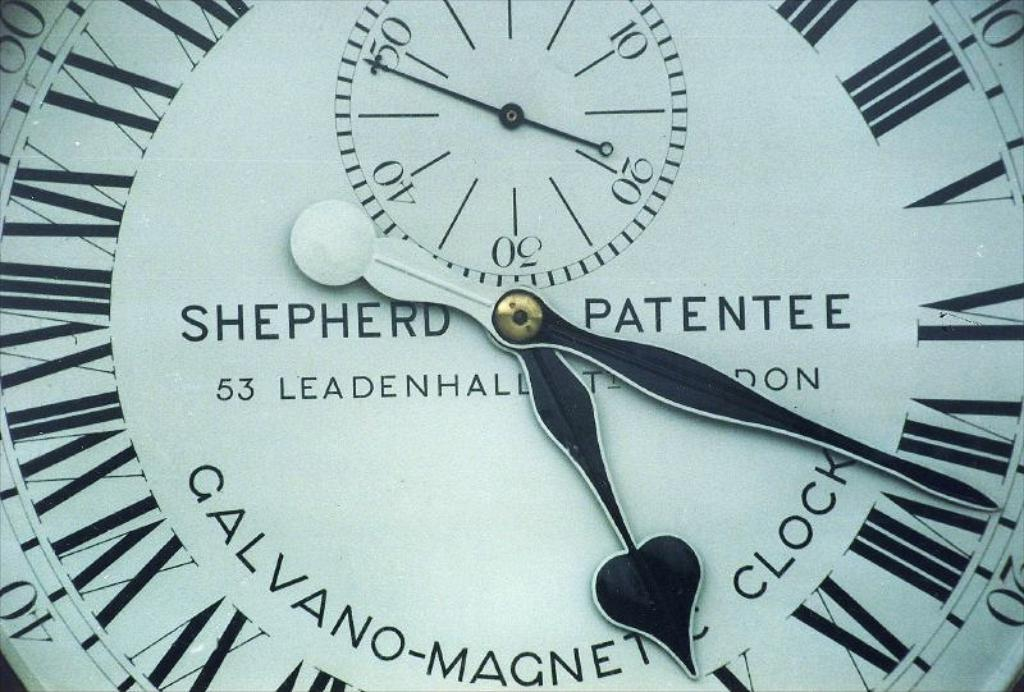<image>
Give a short and clear explanation of the subsequent image. A Sheperd Patentee watch has a spade symbol on one of its hands 